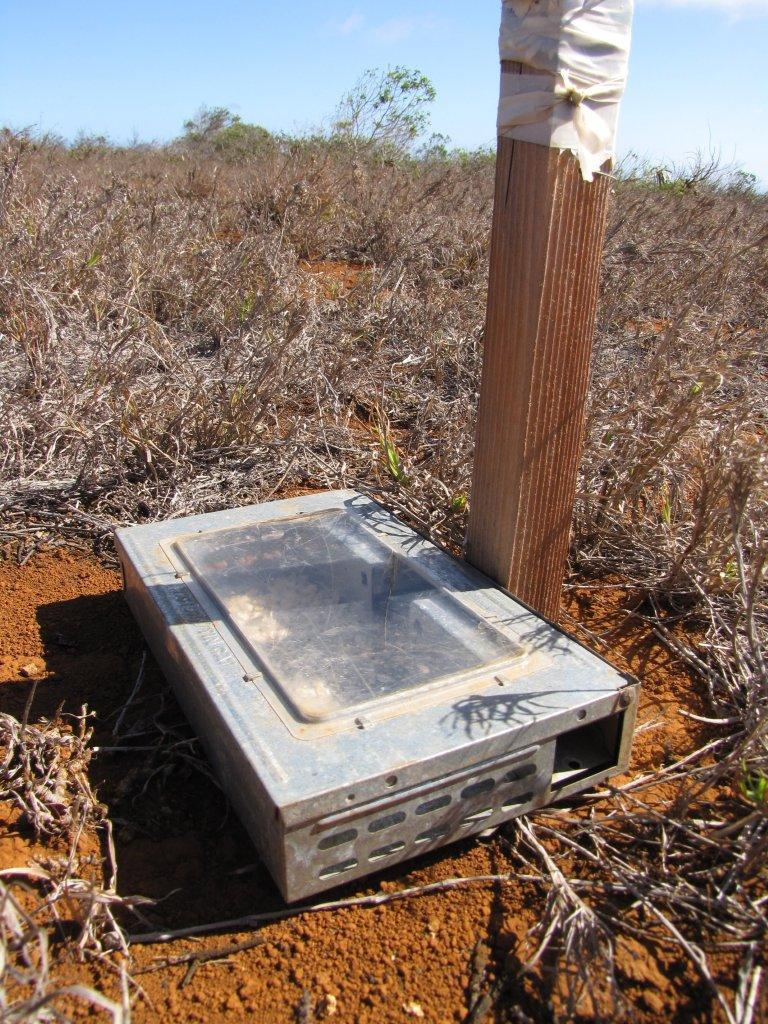What object is the main focus of the image? There is an iron box in the image. What can be seen in the background of the image? The background of the image is the sky. What type of discussion is taking place between the ducks in the image? There are no ducks present in the image, so there is no discussion taking place. How many girls can be seen playing with the iron box in the image? There are no girls present in the image, so there is no one playing with the iron box. 